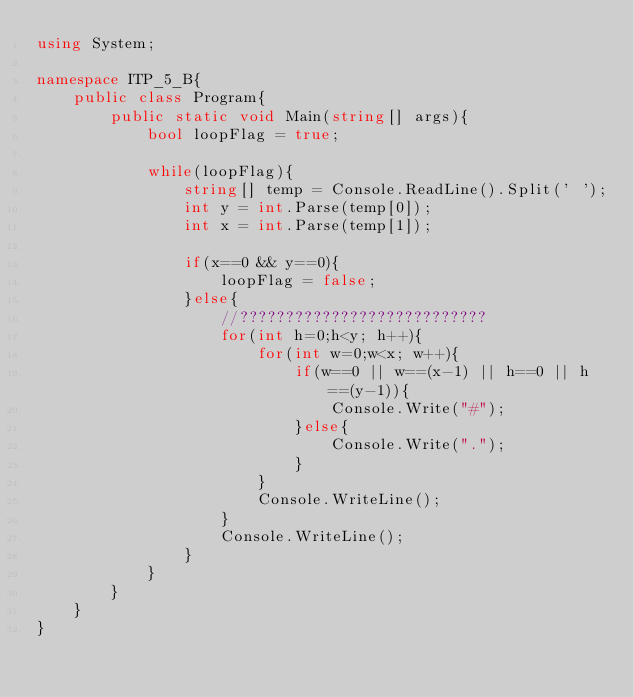Convert code to text. <code><loc_0><loc_0><loc_500><loc_500><_C#_>using System;

namespace ITP_5_B{
    public class Program{
        public static void Main(string[] args){
            bool loopFlag = true;

            while(loopFlag){
                string[] temp = Console.ReadLine().Split(' ');
                int y = int.Parse(temp[0]);
                int x = int.Parse(temp[1]);

                if(x==0 && y==0){
                    loopFlag = false;
                }else{
                    //???????????????????????????
                    for(int h=0;h<y; h++){
                        for(int w=0;w<x; w++){
                            if(w==0 || w==(x-1) || h==0 || h==(y-1)){
                                Console.Write("#");
                            }else{
                                Console.Write(".");
                            }
                        }
                        Console.WriteLine();
                    }
                    Console.WriteLine();
                }
            }
        }
    }
}</code> 